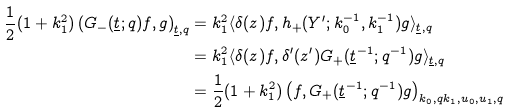<formula> <loc_0><loc_0><loc_500><loc_500>\frac { 1 } { 2 } ( 1 + k _ { 1 } ^ { 2 } ) \left ( G _ { - } ( \underline { t } ; q ) f , g \right ) _ { \underline { t } , q } & = k _ { 1 } ^ { 2 } \langle \delta ( z ) f , h _ { + } ( Y ^ { \prime } ; k _ { 0 } ^ { - 1 } , k _ { 1 } ^ { - 1 } ) g \rangle _ { \underline { t } , q } \\ & = k _ { 1 } ^ { 2 } \langle \delta ( z ) f , \delta ^ { \prime } ( z ^ { \prime } ) G _ { + } ( \underline { t } ^ { - 1 } ; q ^ { - 1 } ) g \rangle _ { \underline { t } , q } \\ & = \frac { 1 } { 2 } ( 1 + k _ { 1 } ^ { 2 } ) \left ( f , G _ { + } ( \underline { t } ^ { - 1 } ; q ^ { - 1 } ) g \right ) _ { k _ { 0 } , q k _ { 1 } , u _ { 0 } , u _ { 1 } , q }</formula> 